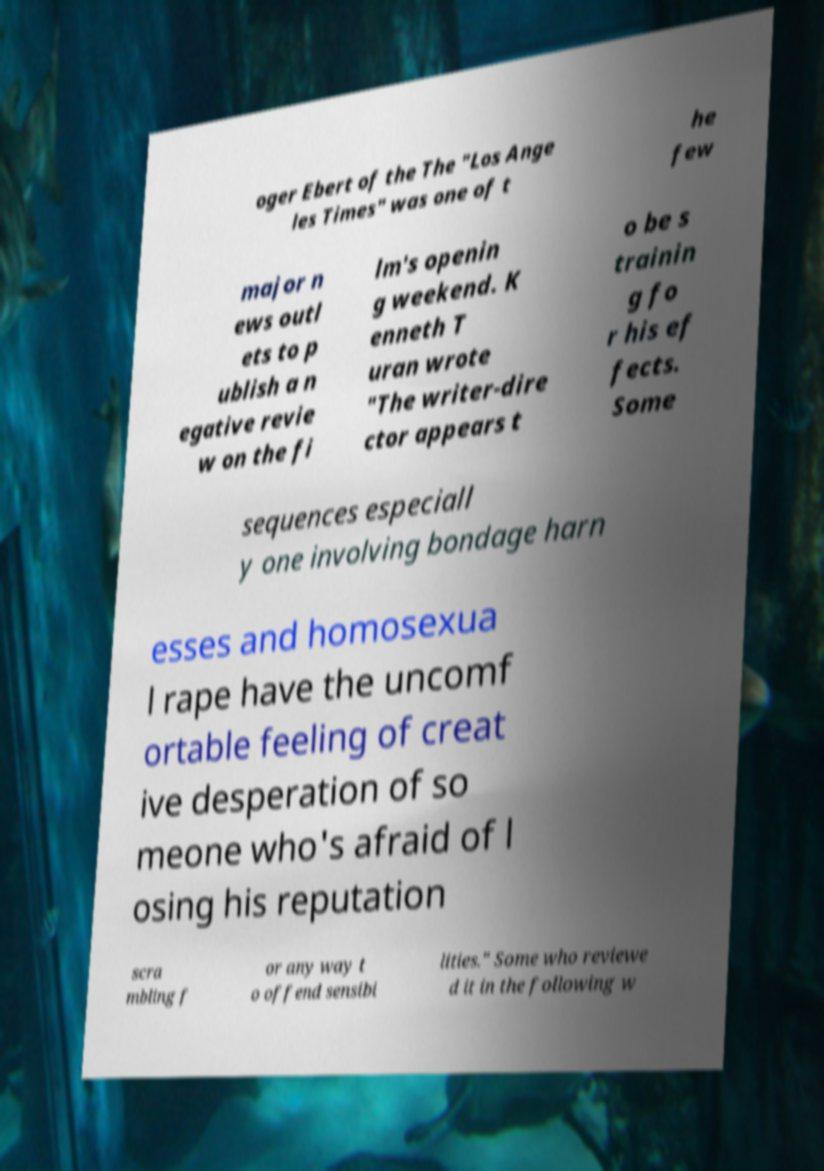I need the written content from this picture converted into text. Can you do that? oger Ebert of the The "Los Ange les Times" was one of t he few major n ews outl ets to p ublish a n egative revie w on the fi lm's openin g weekend. K enneth T uran wrote "The writer-dire ctor appears t o be s trainin g fo r his ef fects. Some sequences especiall y one involving bondage harn esses and homosexua l rape have the uncomf ortable feeling of creat ive desperation of so meone who's afraid of l osing his reputation scra mbling f or any way t o offend sensibi lities." Some who reviewe d it in the following w 